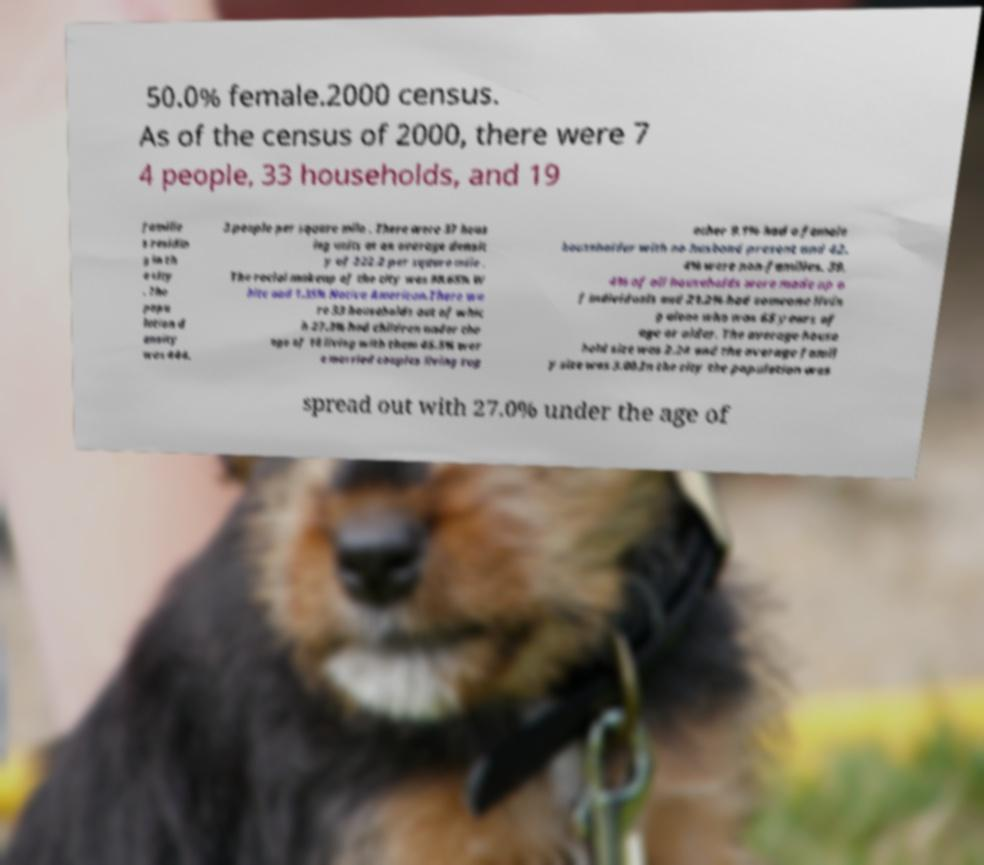There's text embedded in this image that I need extracted. Can you transcribe it verbatim? 50.0% female.2000 census. As of the census of 2000, there were 7 4 people, 33 households, and 19 familie s residin g in th e city . The popu lation d ensity was 444. 3 people per square mile . There were 37 hous ing units at an average densit y of 222.2 per square mile . The racial makeup of the city was 98.65% W hite and 1.35% Native American.There we re 33 households out of whic h 27.3% had children under the age of 18 living with them 45.5% wer e married couples living tog ether 9.1% had a female householder with no husband present and 42. 4% were non-families. 39. 4% of all households were made up o f individuals and 21.2% had someone livin g alone who was 65 years of age or older. The average house hold size was 2.24 and the average famil y size was 3.00.In the city the population was spread out with 27.0% under the age of 